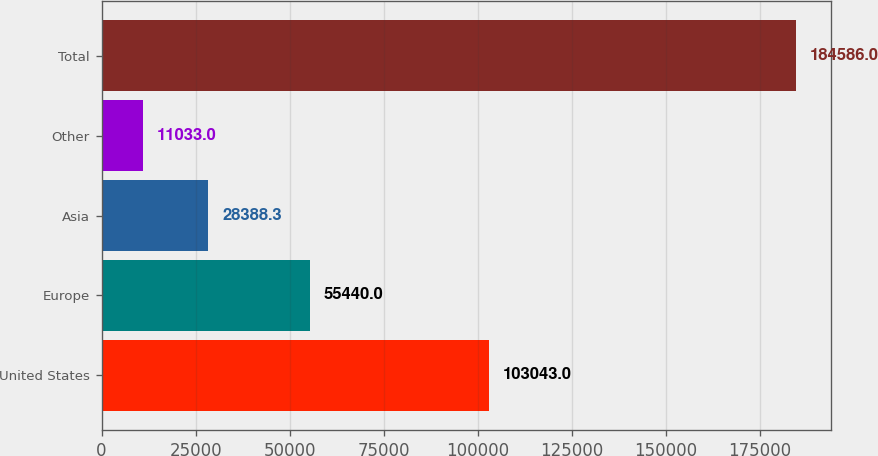Convert chart. <chart><loc_0><loc_0><loc_500><loc_500><bar_chart><fcel>United States<fcel>Europe<fcel>Asia<fcel>Other<fcel>Total<nl><fcel>103043<fcel>55440<fcel>28388.3<fcel>11033<fcel>184586<nl></chart> 